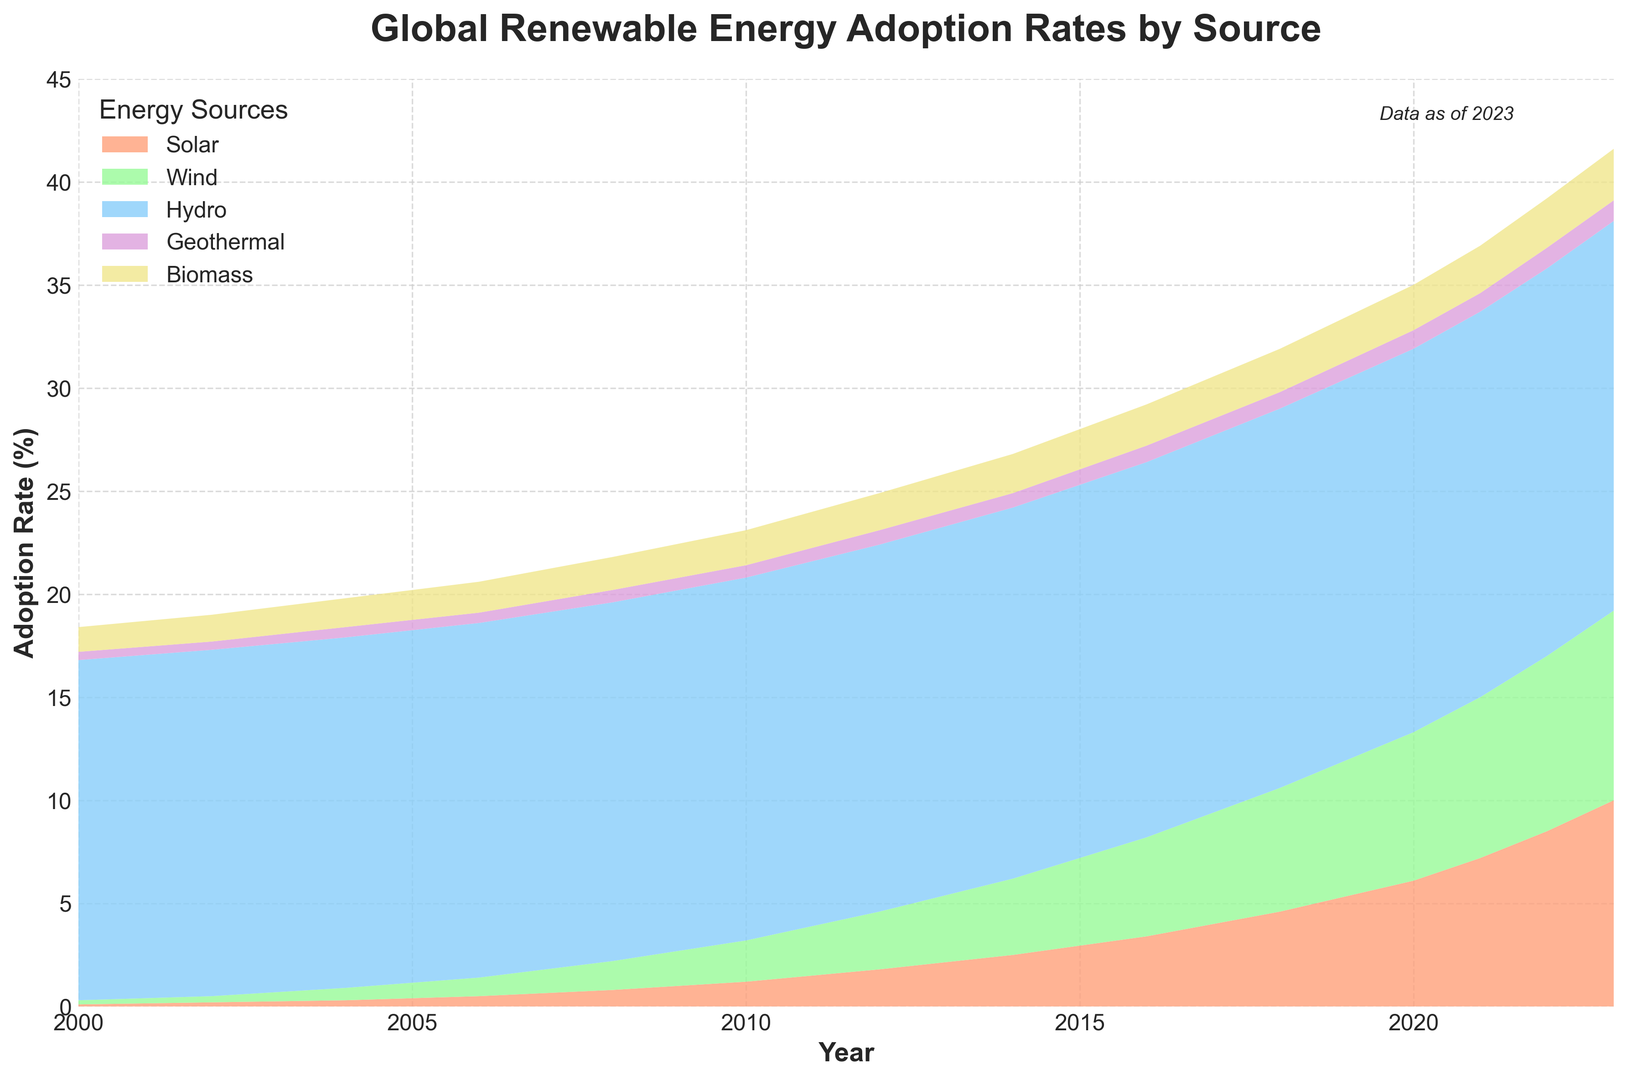How does the adoption rate of solar energy in 2023 compare to 2000? Compare the values for solar energy in 2023 (10.0%) and 2000 (0.1%).
Answer: Solar energy adoption increased from 0.1% in 2000 to 10.0% in 2023 Which renewable energy source has seen the most significant increase in adoption rates from 2000 to 2023? Examine the adoption rate values for each source in 2000 and 2023. Solar increased from 0.1% to 10.0%, which is the most significant increase.
Answer: Solar energy In which year did wind energy adoption first exceed 2%? Locate the years and corresponding adoption rates for wind energy. Wind energy adoption rate first exceeded 2% in 2010.
Answer: 2010 What are the combined adoption rates of wind and biomass in 2020? Sum the adoption rates for wind (7.2%) and biomass (2.2%) in 2020.
Answer: 9.4% Which energy source had the least change in adoption rates between 2000 and 2023? Evaluate the changes in adoption rates for each source. Hydro increased from 16.5% to 18.9%, which is the smallest change.
Answer: Hydro By how much did geothermal energy adoption rate increase from 2010 to 2023? Subtract the 2010 adoption rate for geothermal energy (0.6%) from the 2023 rate (1.0%).
Answer: 0.4% How do the adoption rates of solar and wind energy in 2023 compare? Compare the adoption rates for solar (10.0%) and wind (9.2%) in 2023.
Answer: Solar energy has a higher adoption rate than wind energy by 0.8% What was the total adoption rate of all renewable energies in 2004? Sum the adoption rates of all sources for 2004: Solar (0.3%) + Wind (0.6%) + Hydro (17.0%) + Geothermal (0.5%) + Biomass (1.4%).
Answer: 19.8% Which renewable energy sources had an adoption rate of exactly 0.9% in any given year? Identify any energy sources with a 0.9% adoption rate. Both wind in 2008 and geothermal in 2020 and 2021 had adoption rates of 0.9%.
Answer: Wind and Geothermal What is the average adoption rate of biomass energy over the years presented? Calculate the average of the biomass adoption rates: mean([1.2, 1.3, 1.4, 1.5, 1.6, 1.7, 1.8, 1.9, 2.0, 2.1, 2.2, 2.3, 2.4, 2.5]).
Answer: 1.83% 